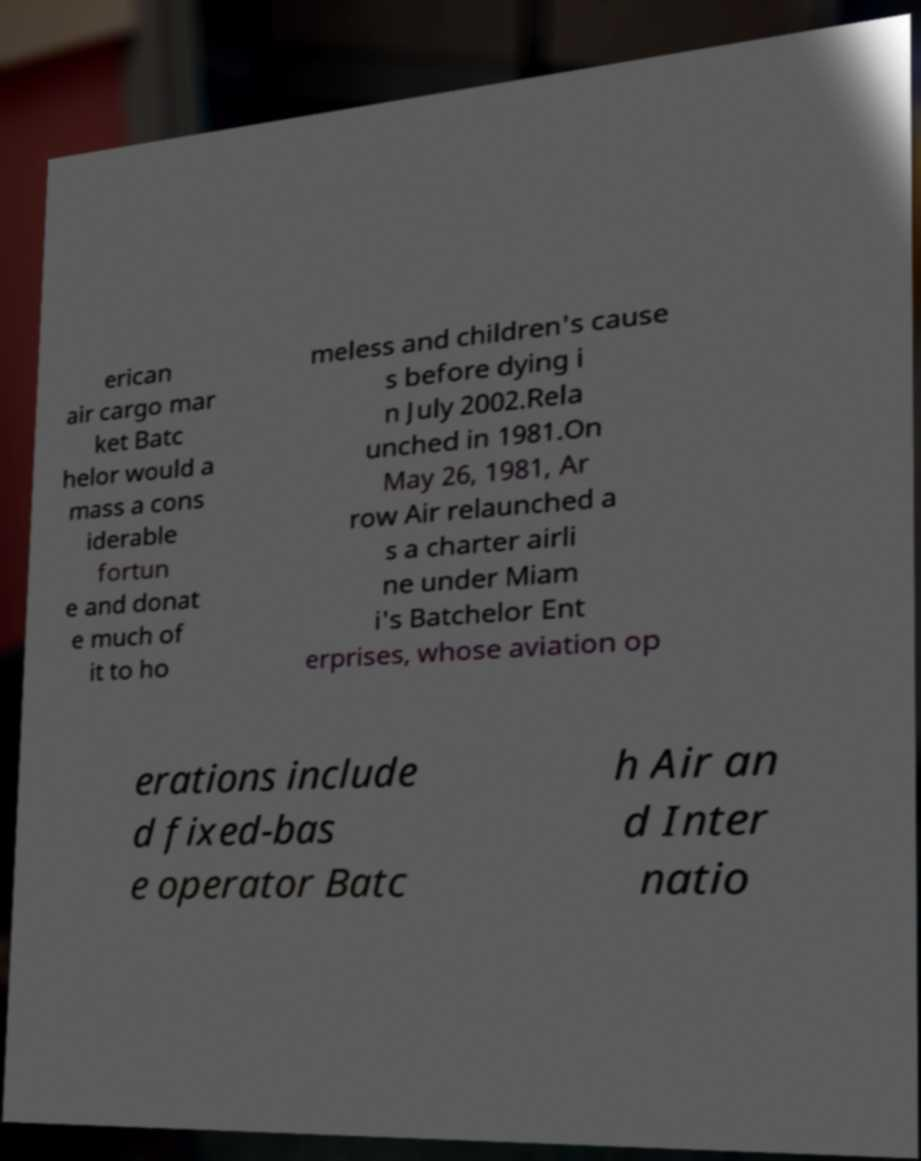Can you accurately transcribe the text from the provided image for me? erican air cargo mar ket Batc helor would a mass a cons iderable fortun e and donat e much of it to ho meless and children's cause s before dying i n July 2002.Rela unched in 1981.On May 26, 1981, Ar row Air relaunched a s a charter airli ne under Miam i's Batchelor Ent erprises, whose aviation op erations include d fixed-bas e operator Batc h Air an d Inter natio 